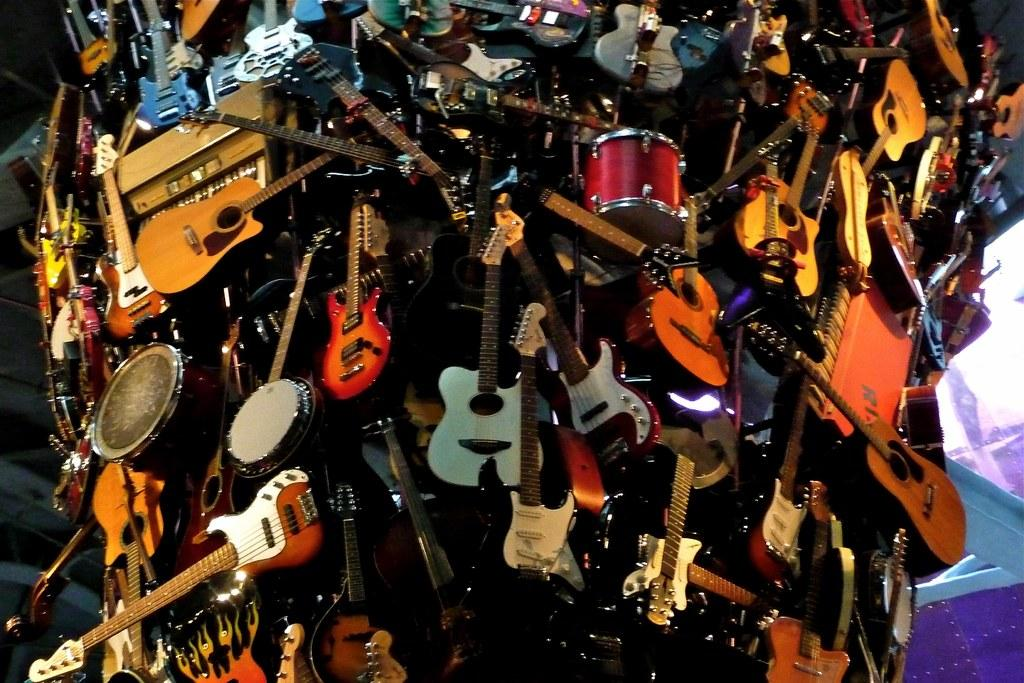What type of objects can be seen in the image? There are musical instruments in the image. Can you describe the musical instruments in more detail? Unfortunately, the provided facts do not give enough information to describe the musical instruments in more detail. Are there any other objects or people present in the image? The provided facts do not mention any other objects or people in the image. How much money is being exchanged between the musicians in the image? There is no mention of money or any exchange of money in the image. The image only shows musical instruments. 